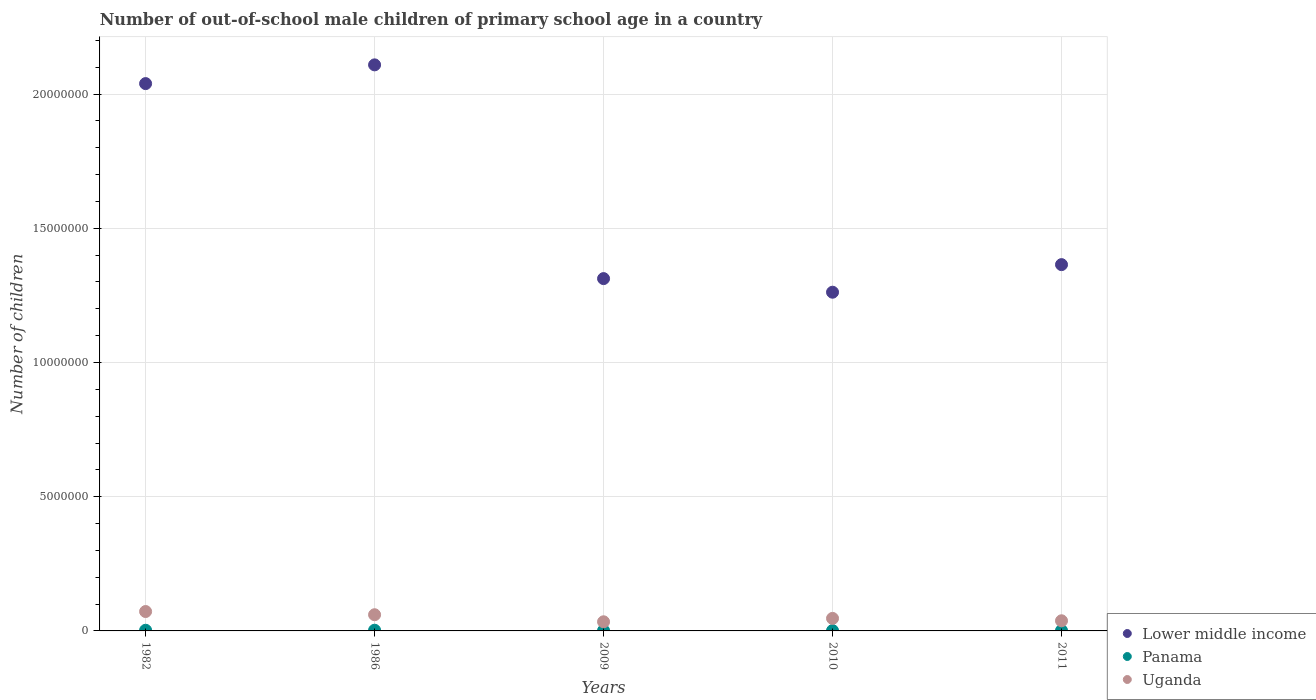Is the number of dotlines equal to the number of legend labels?
Make the answer very short. Yes. What is the number of out-of-school male children in Panama in 2009?
Give a very brief answer. 1.60e+04. Across all years, what is the maximum number of out-of-school male children in Panama?
Offer a terse response. 2.62e+04. Across all years, what is the minimum number of out-of-school male children in Panama?
Your response must be concise. 1.28e+04. In which year was the number of out-of-school male children in Lower middle income minimum?
Give a very brief answer. 2010. What is the total number of out-of-school male children in Panama in the graph?
Give a very brief answer. 9.62e+04. What is the difference between the number of out-of-school male children in Uganda in 2009 and that in 2011?
Provide a short and direct response. -3.75e+04. What is the difference between the number of out-of-school male children in Panama in 1982 and the number of out-of-school male children in Uganda in 2010?
Provide a short and direct response. -4.42e+05. What is the average number of out-of-school male children in Panama per year?
Ensure brevity in your answer.  1.92e+04. In the year 1986, what is the difference between the number of out-of-school male children in Panama and number of out-of-school male children in Uganda?
Your answer should be compact. -5.77e+05. In how many years, is the number of out-of-school male children in Lower middle income greater than 5000000?
Keep it short and to the point. 5. What is the ratio of the number of out-of-school male children in Lower middle income in 2009 to that in 2010?
Your response must be concise. 1.04. Is the difference between the number of out-of-school male children in Panama in 1982 and 1986 greater than the difference between the number of out-of-school male children in Uganda in 1982 and 1986?
Ensure brevity in your answer.  No. What is the difference between the highest and the second highest number of out-of-school male children in Lower middle income?
Provide a succinct answer. 6.98e+05. What is the difference between the highest and the lowest number of out-of-school male children in Panama?
Ensure brevity in your answer.  1.34e+04. Is the sum of the number of out-of-school male children in Panama in 2010 and 2011 greater than the maximum number of out-of-school male children in Lower middle income across all years?
Make the answer very short. No. Does the number of out-of-school male children in Uganda monotonically increase over the years?
Offer a very short reply. No. Is the number of out-of-school male children in Uganda strictly greater than the number of out-of-school male children in Lower middle income over the years?
Offer a very short reply. No. Is the number of out-of-school male children in Lower middle income strictly less than the number of out-of-school male children in Panama over the years?
Your response must be concise. No. How many years are there in the graph?
Your response must be concise. 5. Are the values on the major ticks of Y-axis written in scientific E-notation?
Offer a very short reply. No. Does the graph contain any zero values?
Provide a succinct answer. No. Where does the legend appear in the graph?
Ensure brevity in your answer.  Bottom right. How are the legend labels stacked?
Ensure brevity in your answer.  Vertical. What is the title of the graph?
Your answer should be compact. Number of out-of-school male children of primary school age in a country. Does "Aruba" appear as one of the legend labels in the graph?
Ensure brevity in your answer.  No. What is the label or title of the X-axis?
Make the answer very short. Years. What is the label or title of the Y-axis?
Provide a short and direct response. Number of children. What is the Number of children in Lower middle income in 1982?
Offer a very short reply. 2.04e+07. What is the Number of children of Panama in 1982?
Your answer should be very brief. 2.49e+04. What is the Number of children in Uganda in 1982?
Give a very brief answer. 7.22e+05. What is the Number of children in Lower middle income in 1986?
Your answer should be very brief. 2.11e+07. What is the Number of children of Panama in 1986?
Provide a short and direct response. 2.62e+04. What is the Number of children in Uganda in 1986?
Your response must be concise. 6.03e+05. What is the Number of children in Lower middle income in 2009?
Give a very brief answer. 1.31e+07. What is the Number of children in Panama in 2009?
Offer a terse response. 1.60e+04. What is the Number of children in Uganda in 2009?
Your response must be concise. 3.40e+05. What is the Number of children in Lower middle income in 2010?
Provide a succinct answer. 1.26e+07. What is the Number of children in Panama in 2010?
Your response must be concise. 1.28e+04. What is the Number of children of Uganda in 2010?
Provide a short and direct response. 4.67e+05. What is the Number of children in Lower middle income in 2011?
Offer a terse response. 1.36e+07. What is the Number of children in Panama in 2011?
Offer a terse response. 1.64e+04. What is the Number of children in Uganda in 2011?
Your response must be concise. 3.78e+05. Across all years, what is the maximum Number of children of Lower middle income?
Provide a short and direct response. 2.11e+07. Across all years, what is the maximum Number of children in Panama?
Keep it short and to the point. 2.62e+04. Across all years, what is the maximum Number of children in Uganda?
Provide a succinct answer. 7.22e+05. Across all years, what is the minimum Number of children in Lower middle income?
Offer a very short reply. 1.26e+07. Across all years, what is the minimum Number of children of Panama?
Keep it short and to the point. 1.28e+04. Across all years, what is the minimum Number of children of Uganda?
Offer a terse response. 3.40e+05. What is the total Number of children in Lower middle income in the graph?
Your answer should be very brief. 8.09e+07. What is the total Number of children in Panama in the graph?
Your answer should be very brief. 9.62e+04. What is the total Number of children of Uganda in the graph?
Offer a terse response. 2.51e+06. What is the difference between the Number of children of Lower middle income in 1982 and that in 1986?
Offer a terse response. -6.98e+05. What is the difference between the Number of children in Panama in 1982 and that in 1986?
Offer a very short reply. -1287. What is the difference between the Number of children in Uganda in 1982 and that in 1986?
Your answer should be compact. 1.19e+05. What is the difference between the Number of children in Lower middle income in 1982 and that in 2009?
Make the answer very short. 7.26e+06. What is the difference between the Number of children of Panama in 1982 and that in 2009?
Provide a succinct answer. 8922. What is the difference between the Number of children in Uganda in 1982 and that in 2009?
Your response must be concise. 3.82e+05. What is the difference between the Number of children in Lower middle income in 1982 and that in 2010?
Provide a short and direct response. 7.77e+06. What is the difference between the Number of children of Panama in 1982 and that in 2010?
Give a very brief answer. 1.21e+04. What is the difference between the Number of children of Uganda in 1982 and that in 2010?
Provide a succinct answer. 2.56e+05. What is the difference between the Number of children in Lower middle income in 1982 and that in 2011?
Keep it short and to the point. 6.74e+06. What is the difference between the Number of children of Panama in 1982 and that in 2011?
Provide a succinct answer. 8513. What is the difference between the Number of children of Uganda in 1982 and that in 2011?
Your answer should be compact. 3.45e+05. What is the difference between the Number of children in Lower middle income in 1986 and that in 2009?
Offer a terse response. 7.96e+06. What is the difference between the Number of children of Panama in 1986 and that in 2009?
Ensure brevity in your answer.  1.02e+04. What is the difference between the Number of children of Uganda in 1986 and that in 2009?
Provide a succinct answer. 2.63e+05. What is the difference between the Number of children of Lower middle income in 1986 and that in 2010?
Ensure brevity in your answer.  8.47e+06. What is the difference between the Number of children in Panama in 1986 and that in 2010?
Offer a terse response. 1.34e+04. What is the difference between the Number of children of Uganda in 1986 and that in 2010?
Your answer should be very brief. 1.36e+05. What is the difference between the Number of children of Lower middle income in 1986 and that in 2011?
Provide a short and direct response. 7.44e+06. What is the difference between the Number of children in Panama in 1986 and that in 2011?
Your response must be concise. 9800. What is the difference between the Number of children of Uganda in 1986 and that in 2011?
Ensure brevity in your answer.  2.25e+05. What is the difference between the Number of children of Lower middle income in 2009 and that in 2010?
Provide a succinct answer. 5.07e+05. What is the difference between the Number of children in Panama in 2009 and that in 2010?
Your answer should be compact. 3159. What is the difference between the Number of children of Uganda in 2009 and that in 2010?
Make the answer very short. -1.26e+05. What is the difference between the Number of children of Lower middle income in 2009 and that in 2011?
Give a very brief answer. -5.20e+05. What is the difference between the Number of children in Panama in 2009 and that in 2011?
Offer a terse response. -409. What is the difference between the Number of children in Uganda in 2009 and that in 2011?
Your answer should be very brief. -3.75e+04. What is the difference between the Number of children in Lower middle income in 2010 and that in 2011?
Offer a terse response. -1.03e+06. What is the difference between the Number of children in Panama in 2010 and that in 2011?
Your answer should be compact. -3568. What is the difference between the Number of children of Uganda in 2010 and that in 2011?
Your answer should be compact. 8.87e+04. What is the difference between the Number of children of Lower middle income in 1982 and the Number of children of Panama in 1986?
Give a very brief answer. 2.04e+07. What is the difference between the Number of children of Lower middle income in 1982 and the Number of children of Uganda in 1986?
Ensure brevity in your answer.  1.98e+07. What is the difference between the Number of children in Panama in 1982 and the Number of children in Uganda in 1986?
Provide a succinct answer. -5.78e+05. What is the difference between the Number of children in Lower middle income in 1982 and the Number of children in Panama in 2009?
Offer a very short reply. 2.04e+07. What is the difference between the Number of children in Lower middle income in 1982 and the Number of children in Uganda in 2009?
Offer a terse response. 2.00e+07. What is the difference between the Number of children in Panama in 1982 and the Number of children in Uganda in 2009?
Make the answer very short. -3.16e+05. What is the difference between the Number of children in Lower middle income in 1982 and the Number of children in Panama in 2010?
Give a very brief answer. 2.04e+07. What is the difference between the Number of children in Lower middle income in 1982 and the Number of children in Uganda in 2010?
Your answer should be compact. 1.99e+07. What is the difference between the Number of children of Panama in 1982 and the Number of children of Uganda in 2010?
Your answer should be compact. -4.42e+05. What is the difference between the Number of children in Lower middle income in 1982 and the Number of children in Panama in 2011?
Your response must be concise. 2.04e+07. What is the difference between the Number of children of Lower middle income in 1982 and the Number of children of Uganda in 2011?
Your response must be concise. 2.00e+07. What is the difference between the Number of children in Panama in 1982 and the Number of children in Uganda in 2011?
Provide a short and direct response. -3.53e+05. What is the difference between the Number of children in Lower middle income in 1986 and the Number of children in Panama in 2009?
Give a very brief answer. 2.11e+07. What is the difference between the Number of children in Lower middle income in 1986 and the Number of children in Uganda in 2009?
Offer a terse response. 2.07e+07. What is the difference between the Number of children of Panama in 1986 and the Number of children of Uganda in 2009?
Make the answer very short. -3.14e+05. What is the difference between the Number of children of Lower middle income in 1986 and the Number of children of Panama in 2010?
Provide a succinct answer. 2.11e+07. What is the difference between the Number of children in Lower middle income in 1986 and the Number of children in Uganda in 2010?
Ensure brevity in your answer.  2.06e+07. What is the difference between the Number of children of Panama in 1986 and the Number of children of Uganda in 2010?
Your answer should be very brief. -4.40e+05. What is the difference between the Number of children of Lower middle income in 1986 and the Number of children of Panama in 2011?
Give a very brief answer. 2.11e+07. What is the difference between the Number of children in Lower middle income in 1986 and the Number of children in Uganda in 2011?
Give a very brief answer. 2.07e+07. What is the difference between the Number of children of Panama in 1986 and the Number of children of Uganda in 2011?
Offer a very short reply. -3.52e+05. What is the difference between the Number of children in Lower middle income in 2009 and the Number of children in Panama in 2010?
Provide a short and direct response. 1.31e+07. What is the difference between the Number of children in Lower middle income in 2009 and the Number of children in Uganda in 2010?
Make the answer very short. 1.27e+07. What is the difference between the Number of children of Panama in 2009 and the Number of children of Uganda in 2010?
Your answer should be very brief. -4.51e+05. What is the difference between the Number of children of Lower middle income in 2009 and the Number of children of Panama in 2011?
Your answer should be very brief. 1.31e+07. What is the difference between the Number of children in Lower middle income in 2009 and the Number of children in Uganda in 2011?
Your response must be concise. 1.27e+07. What is the difference between the Number of children of Panama in 2009 and the Number of children of Uganda in 2011?
Make the answer very short. -3.62e+05. What is the difference between the Number of children of Lower middle income in 2010 and the Number of children of Panama in 2011?
Keep it short and to the point. 1.26e+07. What is the difference between the Number of children of Lower middle income in 2010 and the Number of children of Uganda in 2011?
Offer a terse response. 1.22e+07. What is the difference between the Number of children of Panama in 2010 and the Number of children of Uganda in 2011?
Ensure brevity in your answer.  -3.65e+05. What is the average Number of children in Lower middle income per year?
Give a very brief answer. 1.62e+07. What is the average Number of children of Panama per year?
Make the answer very short. 1.92e+04. What is the average Number of children in Uganda per year?
Your response must be concise. 5.02e+05. In the year 1982, what is the difference between the Number of children in Lower middle income and Number of children in Panama?
Ensure brevity in your answer.  2.04e+07. In the year 1982, what is the difference between the Number of children in Lower middle income and Number of children in Uganda?
Keep it short and to the point. 1.97e+07. In the year 1982, what is the difference between the Number of children of Panama and Number of children of Uganda?
Provide a succinct answer. -6.98e+05. In the year 1986, what is the difference between the Number of children in Lower middle income and Number of children in Panama?
Provide a succinct answer. 2.11e+07. In the year 1986, what is the difference between the Number of children in Lower middle income and Number of children in Uganda?
Ensure brevity in your answer.  2.05e+07. In the year 1986, what is the difference between the Number of children in Panama and Number of children in Uganda?
Keep it short and to the point. -5.77e+05. In the year 2009, what is the difference between the Number of children in Lower middle income and Number of children in Panama?
Ensure brevity in your answer.  1.31e+07. In the year 2009, what is the difference between the Number of children in Lower middle income and Number of children in Uganda?
Provide a short and direct response. 1.28e+07. In the year 2009, what is the difference between the Number of children of Panama and Number of children of Uganda?
Provide a short and direct response. -3.24e+05. In the year 2010, what is the difference between the Number of children of Lower middle income and Number of children of Panama?
Your answer should be compact. 1.26e+07. In the year 2010, what is the difference between the Number of children of Lower middle income and Number of children of Uganda?
Your answer should be compact. 1.22e+07. In the year 2010, what is the difference between the Number of children in Panama and Number of children in Uganda?
Your answer should be very brief. -4.54e+05. In the year 2011, what is the difference between the Number of children of Lower middle income and Number of children of Panama?
Offer a terse response. 1.36e+07. In the year 2011, what is the difference between the Number of children in Lower middle income and Number of children in Uganda?
Keep it short and to the point. 1.33e+07. In the year 2011, what is the difference between the Number of children of Panama and Number of children of Uganda?
Keep it short and to the point. -3.62e+05. What is the ratio of the Number of children in Lower middle income in 1982 to that in 1986?
Provide a succinct answer. 0.97. What is the ratio of the Number of children in Panama in 1982 to that in 1986?
Your response must be concise. 0.95. What is the ratio of the Number of children in Uganda in 1982 to that in 1986?
Provide a succinct answer. 1.2. What is the ratio of the Number of children of Lower middle income in 1982 to that in 2009?
Provide a succinct answer. 1.55. What is the ratio of the Number of children of Panama in 1982 to that in 2009?
Give a very brief answer. 1.56. What is the ratio of the Number of children in Uganda in 1982 to that in 2009?
Your answer should be very brief. 2.12. What is the ratio of the Number of children in Lower middle income in 1982 to that in 2010?
Give a very brief answer. 1.62. What is the ratio of the Number of children in Panama in 1982 to that in 2010?
Your response must be concise. 1.94. What is the ratio of the Number of children of Uganda in 1982 to that in 2010?
Your answer should be compact. 1.55. What is the ratio of the Number of children in Lower middle income in 1982 to that in 2011?
Ensure brevity in your answer.  1.49. What is the ratio of the Number of children of Panama in 1982 to that in 2011?
Ensure brevity in your answer.  1.52. What is the ratio of the Number of children in Uganda in 1982 to that in 2011?
Ensure brevity in your answer.  1.91. What is the ratio of the Number of children of Lower middle income in 1986 to that in 2009?
Provide a succinct answer. 1.61. What is the ratio of the Number of children in Panama in 1986 to that in 2009?
Give a very brief answer. 1.64. What is the ratio of the Number of children in Uganda in 1986 to that in 2009?
Give a very brief answer. 1.77. What is the ratio of the Number of children of Lower middle income in 1986 to that in 2010?
Your answer should be very brief. 1.67. What is the ratio of the Number of children of Panama in 1986 to that in 2010?
Your response must be concise. 2.04. What is the ratio of the Number of children of Uganda in 1986 to that in 2010?
Your answer should be compact. 1.29. What is the ratio of the Number of children of Lower middle income in 1986 to that in 2011?
Give a very brief answer. 1.55. What is the ratio of the Number of children of Panama in 1986 to that in 2011?
Offer a terse response. 1.6. What is the ratio of the Number of children of Uganda in 1986 to that in 2011?
Offer a very short reply. 1.6. What is the ratio of the Number of children in Lower middle income in 2009 to that in 2010?
Provide a succinct answer. 1.04. What is the ratio of the Number of children of Panama in 2009 to that in 2010?
Make the answer very short. 1.25. What is the ratio of the Number of children of Uganda in 2009 to that in 2010?
Your answer should be compact. 0.73. What is the ratio of the Number of children in Lower middle income in 2009 to that in 2011?
Provide a succinct answer. 0.96. What is the ratio of the Number of children of Panama in 2009 to that in 2011?
Keep it short and to the point. 0.97. What is the ratio of the Number of children in Uganda in 2009 to that in 2011?
Your answer should be compact. 0.9. What is the ratio of the Number of children of Lower middle income in 2010 to that in 2011?
Your answer should be compact. 0.92. What is the ratio of the Number of children of Panama in 2010 to that in 2011?
Your answer should be compact. 0.78. What is the ratio of the Number of children in Uganda in 2010 to that in 2011?
Your answer should be compact. 1.23. What is the difference between the highest and the second highest Number of children in Lower middle income?
Keep it short and to the point. 6.98e+05. What is the difference between the highest and the second highest Number of children of Panama?
Offer a very short reply. 1287. What is the difference between the highest and the second highest Number of children of Uganda?
Keep it short and to the point. 1.19e+05. What is the difference between the highest and the lowest Number of children in Lower middle income?
Offer a terse response. 8.47e+06. What is the difference between the highest and the lowest Number of children in Panama?
Your response must be concise. 1.34e+04. What is the difference between the highest and the lowest Number of children in Uganda?
Ensure brevity in your answer.  3.82e+05. 